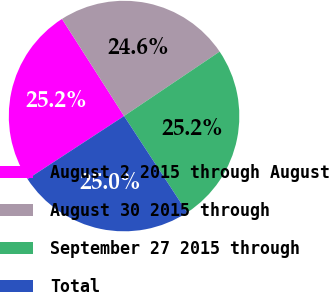Convert chart to OTSL. <chart><loc_0><loc_0><loc_500><loc_500><pie_chart><fcel>August 2 2015 through August<fcel>August 30 2015 through<fcel>September 27 2015 through<fcel>Total<nl><fcel>25.16%<fcel>24.61%<fcel>25.22%<fcel>25.01%<nl></chart> 